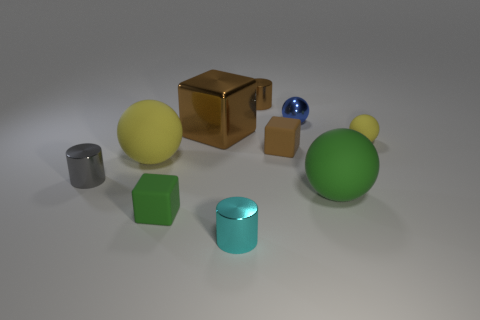Subtract all cubes. How many objects are left? 7 Subtract all brown objects. Subtract all big yellow rubber objects. How many objects are left? 6 Add 3 tiny rubber things. How many tiny rubber things are left? 6 Add 6 brown metallic cylinders. How many brown metallic cylinders exist? 7 Subtract 0 red cylinders. How many objects are left? 10 